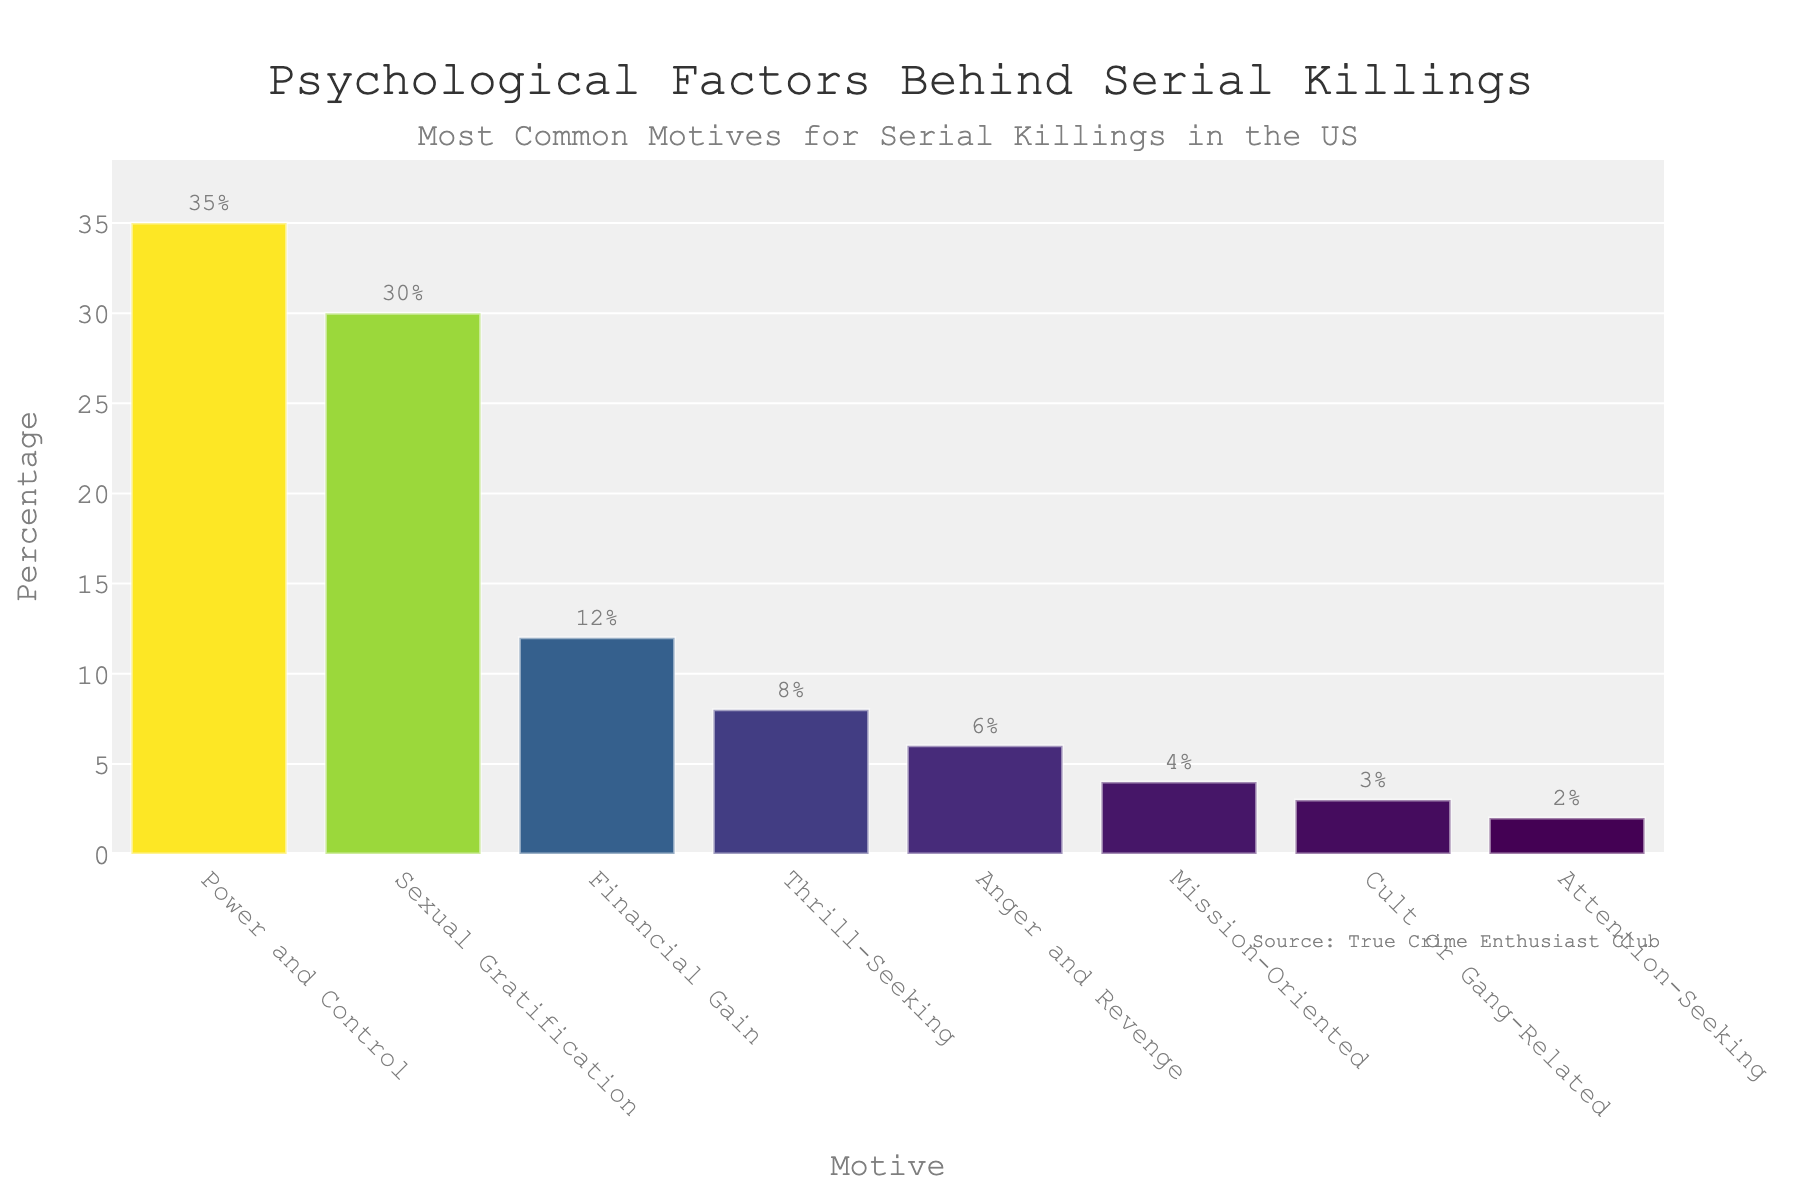Which motive has the highest percentage among serial killings in the US? The motive with the highest percentage is the tallest bar in the chart. From the visual, "Power and Control" has the tallest bar.
Answer: Power and Control What is the sum of the percentages for "Sexual Gratification" and "Financial Gain"? "Sexual Gratification" has 30%, and "Financial Gain" has 12%. Adding these together, 30 + 12 = 42%.
Answer: 42% Is the percentage for "Thrill-Seeking" greater than that for "Anger and Revenge"? "Thrill-Seeking" has a percentage of 8%, and "Anger and Revenge" has a percentage of 6%. Comparing these, 8% is greater than 6%.
Answer: Yes What is the combined percentage of all motives that are less than 8%? The motives less than 8% are "Anger and Revenge" (6%), "Mission-Oriented" (4%), "Cult or Gang-Related" (3%), and "Attention-Seeking" (2%). Adding these together, 6 + 4 + 3 + 2 = 15%.
Answer: 15% How much higher is the percentage for "Power and Control" compared to "Attention-Seeking"? "Power and Control" has 35%, and "Attention-Seeking" has 2%. The difference is 35 - 2 = 33%.
Answer: 33% What is the median percentage value among the listed motives? The percentages sorted in ascending order are 2%, 3%, 4%, 6%, 8%, 12%, 30%, and 35%. The median is the average of the two middle numbers, (6% + 8%)/2 = 7%.
Answer: 7% Which motives have a percentage lower than 5%? The motives with lower than 5% are "Mission-Oriented" (4%), "Cult or Gang-Related" (3%), and "Attention-Seeking" (2%).
Answer: Mission-Oriented, Cult or Gang-Related, Attention-Seeking What is the visual color trend from the bar chart? The bars follow a colorscale from dark to light as the percentage increases, with lighter colors representing higher values.
Answer: Dark to light based on percentage 